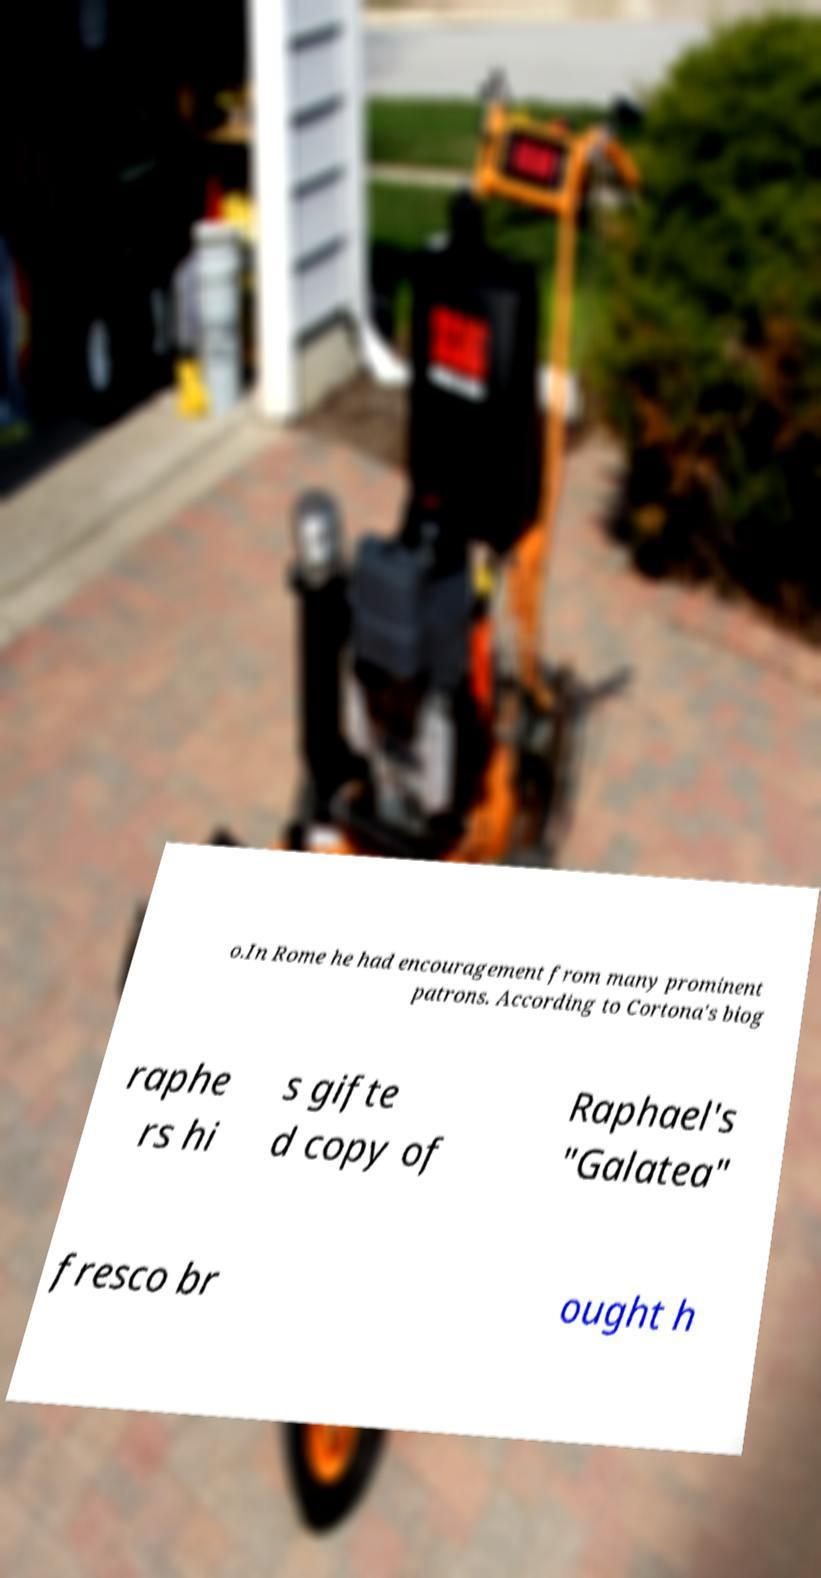Could you assist in decoding the text presented in this image and type it out clearly? o.In Rome he had encouragement from many prominent patrons. According to Cortona's biog raphe rs hi s gifte d copy of Raphael's "Galatea" fresco br ought h 